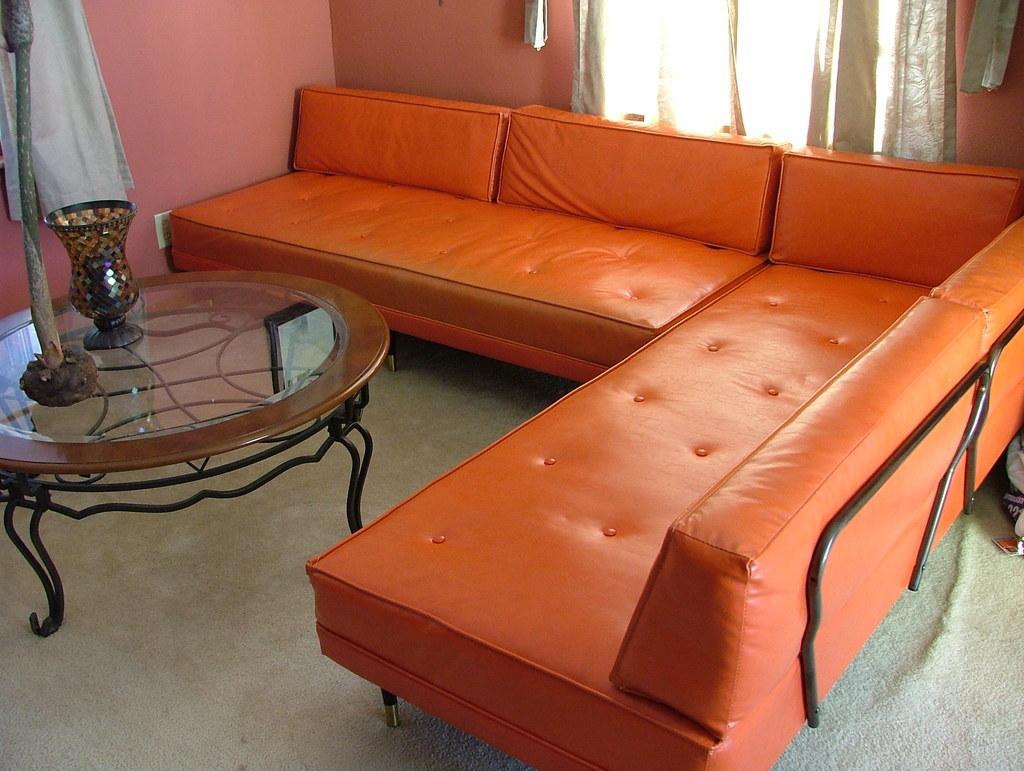Please provide a concise description of this image. In this image there is a sofa of orange colour. At the left side there is a table having a glass and stick on it. At the right side there is a window covered with curtain. At the left side a cloth is hanged to the wall. 